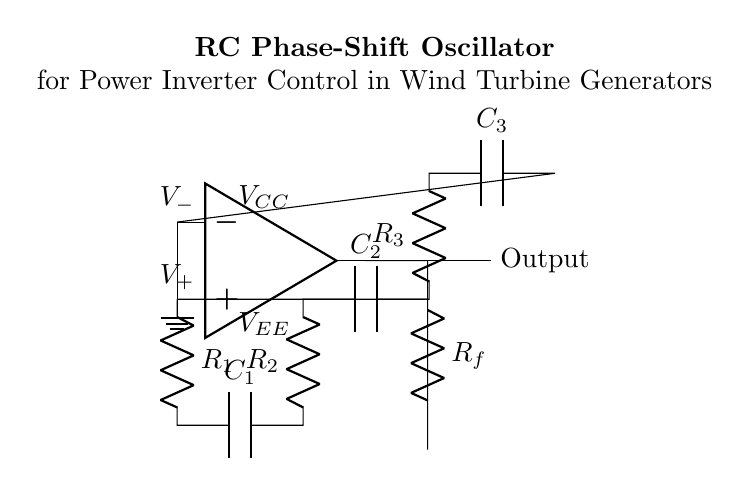What type of oscillator is depicted in the circuit? The circuit is labeled as an RC phase-shift oscillator, indicated both in the title and the components involved.
Answer: RC phase-shift oscillator What components are used in the feedback loop? The feedback loop consists of a resistor labelled R_f, which connects the output of the op-amp back to one of its inputs, thus forming a feedback mechanism.
Answer: Resistor R_f How many resistors are in the RC network? The circuit shows three resistors labelled R_1, R_2, and R_3 in the RC network, which is used to create the necessary phase shifts for oscillation.
Answer: Three What is the role of the capacitors in this oscillator? The capacitors C_1, C_2, and C_3 are used together with the resistors to set the frequency of oscillation by providing the phase shifts required for sustained oscillation.
Answer: Frequency setting What would happen if R_f is removed from the circuit? Removing R_f would eliminate the feedback necessary for oscillation, preventing the circuit from generating the oscillatory output expected from an oscillator design.
Answer: No oscillation What is the function of the op-amp in this circuit? The op-amp amplifies the difference between its input voltages and ensures that the circuit can produce the required output signal for power inverter control.
Answer: Signal amplification How does the phase shift in the RC network contribute to oscillation? Each RC stage provides a phase shift of 60 degrees, and with three stages, the total phase shift becomes 180 degrees, which, combined with the inversion from the op-amp, leads to a total of 360 degrees, essential for oscillation.
Answer: 360 degrees phase shift 